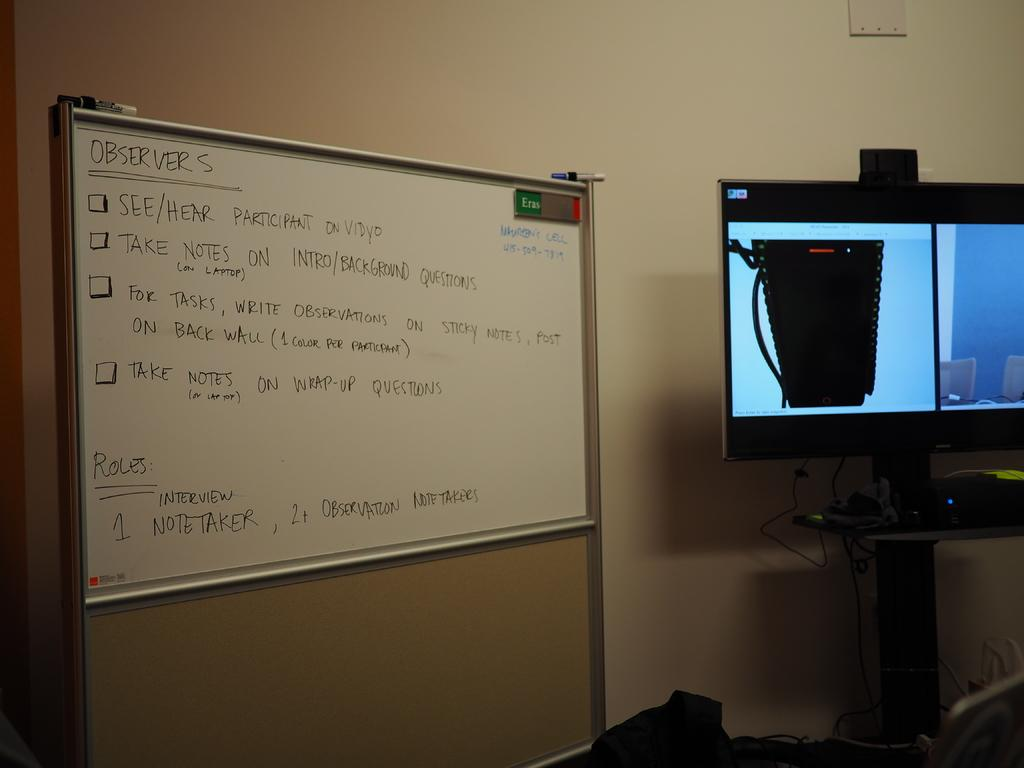<image>
Present a compact description of the photo's key features. A white marker board has the word observers on top of a list. 